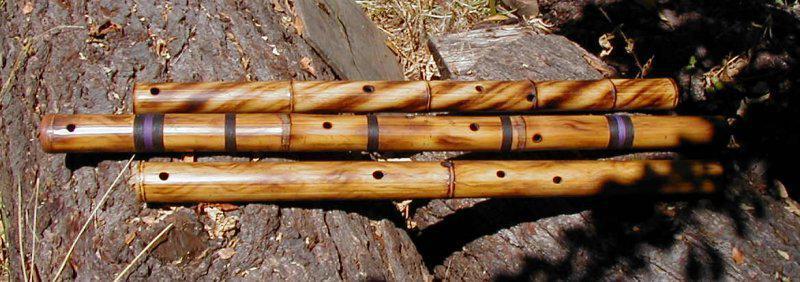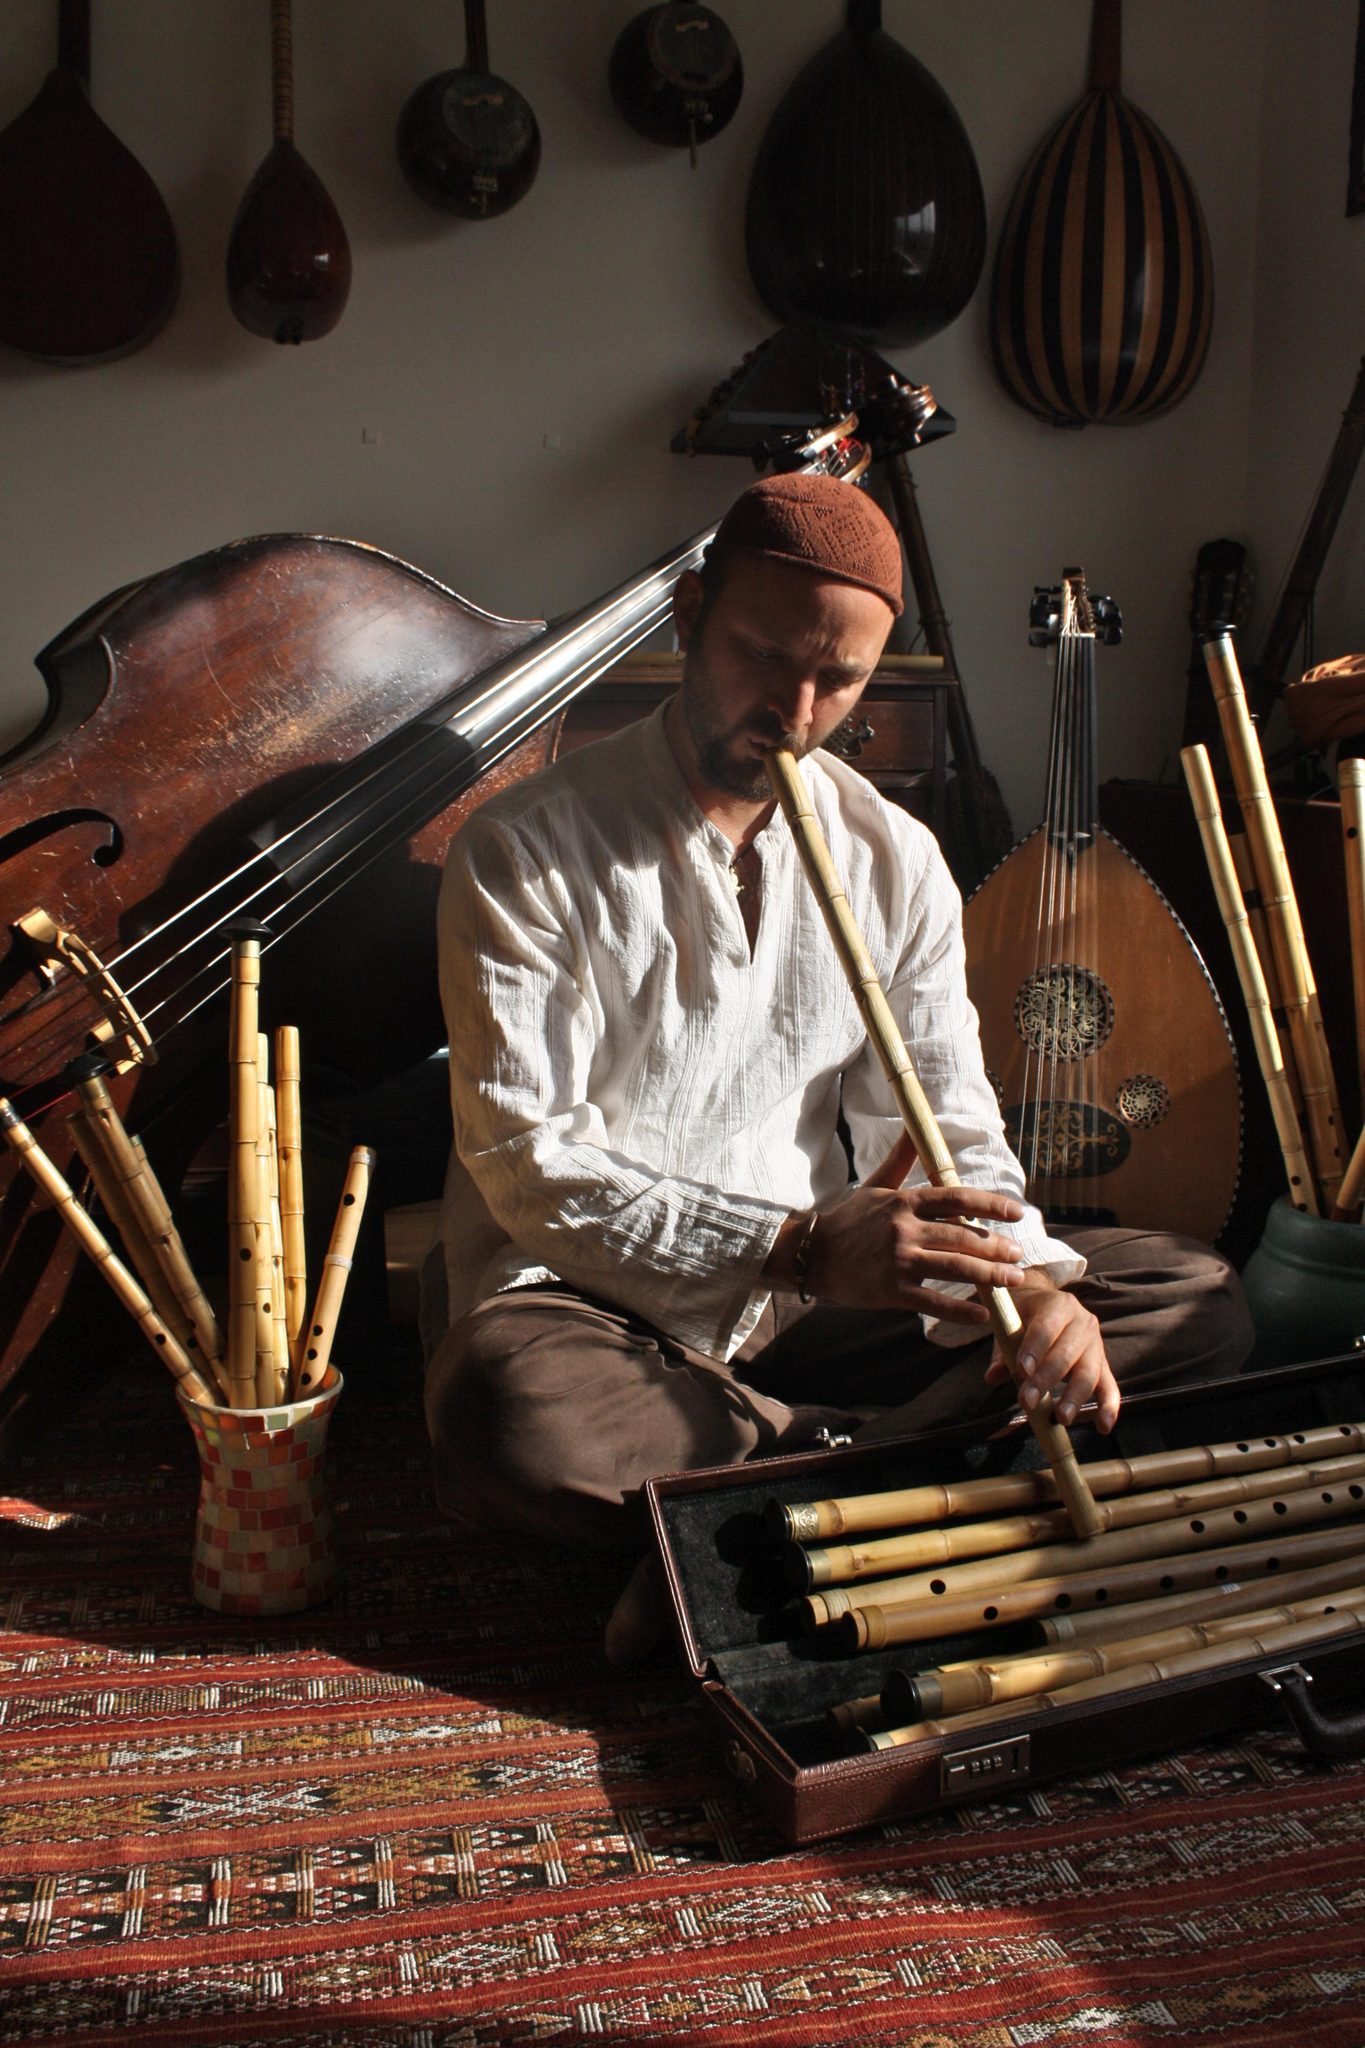The first image is the image on the left, the second image is the image on the right. Examine the images to the left and right. Is the description "There are at least five futes." accurate? Answer yes or no. Yes. 